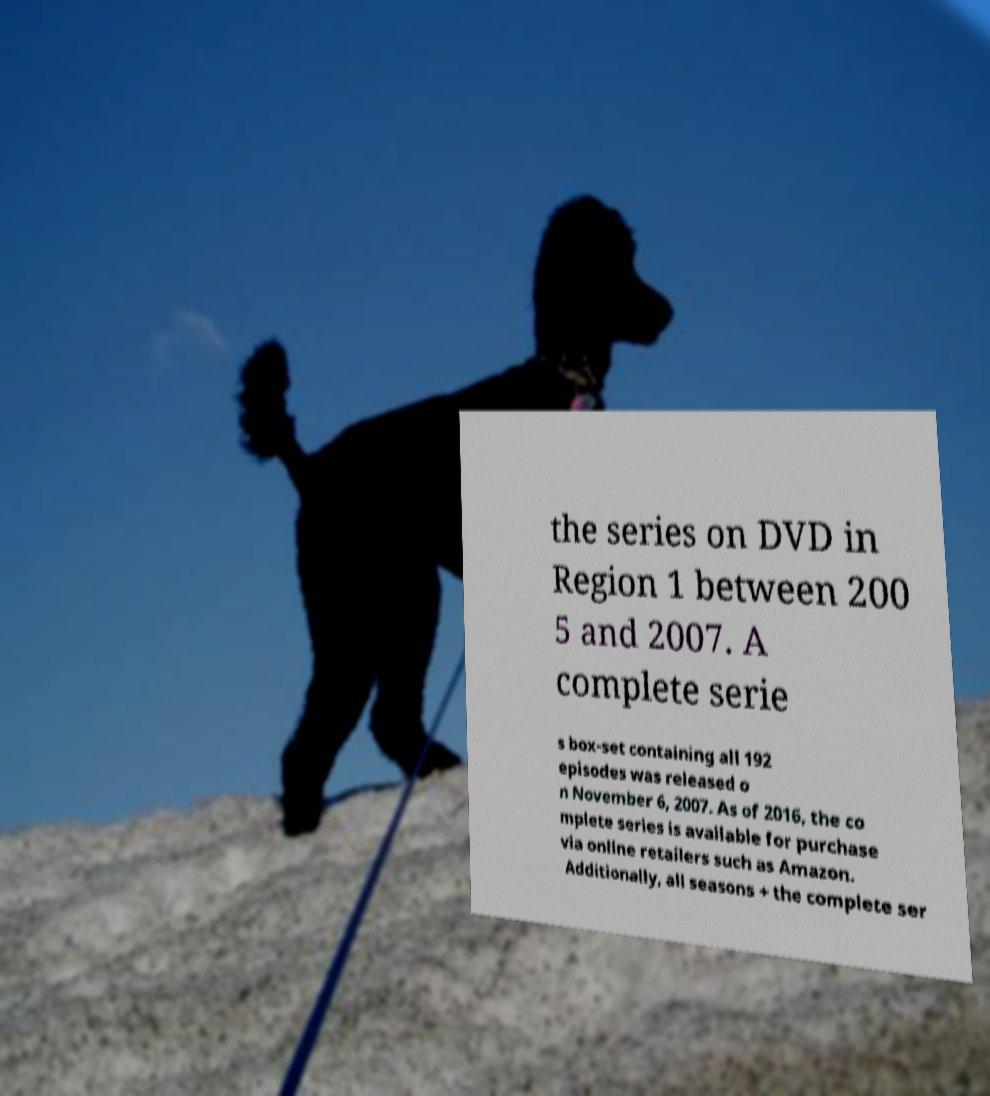Could you extract and type out the text from this image? the series on DVD in Region 1 between 200 5 and 2007. A complete serie s box-set containing all 192 episodes was released o n November 6, 2007. As of 2016, the co mplete series is available for purchase via online retailers such as Amazon. Additionally, all seasons + the complete ser 